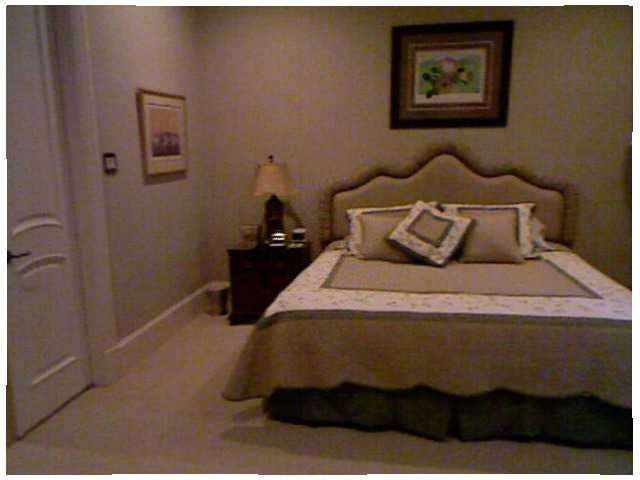<image>
Can you confirm if the bed is under the photo frame? Yes. The bed is positioned underneath the photo frame, with the photo frame above it in the vertical space. Where is the pillow in relation to the bed? Is it on the bed? Yes. Looking at the image, I can see the pillow is positioned on top of the bed, with the bed providing support. Is there a picture on the table? No. The picture is not positioned on the table. They may be near each other, but the picture is not supported by or resting on top of the table. Where is the picture in relation to the bed? Is it behind the bed? Yes. From this viewpoint, the picture is positioned behind the bed, with the bed partially or fully occluding the picture. Is there a wall behind the cot? Yes. From this viewpoint, the wall is positioned behind the cot, with the cot partially or fully occluding the wall. Where is the trash can in relation to the bed? Is it next to the bed? No. The trash can is not positioned next to the bed. They are located in different areas of the scene. 